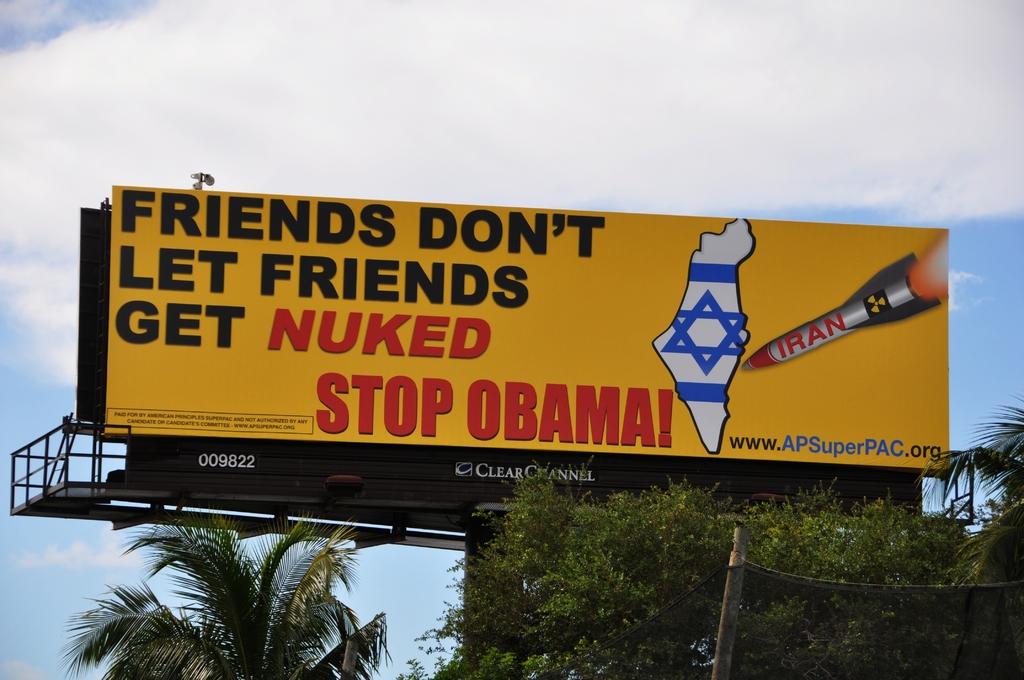What don't friends let friend do?
Your answer should be very brief. Get nuked. Who should be stopped?
Your answer should be very brief. Obama. 